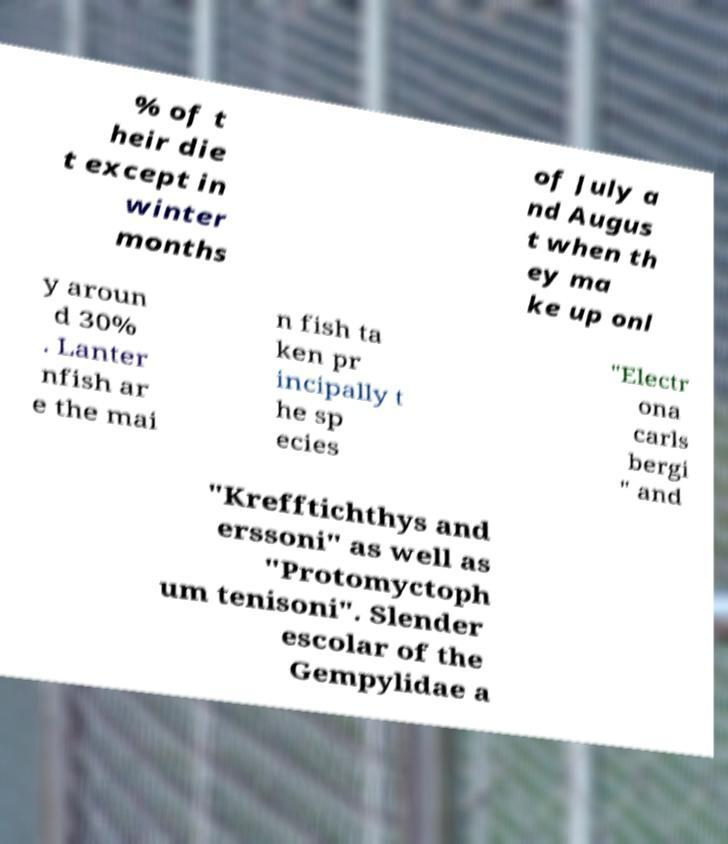For documentation purposes, I need the text within this image transcribed. Could you provide that? % of t heir die t except in winter months of July a nd Augus t when th ey ma ke up onl y aroun d 30% . Lanter nfish ar e the mai n fish ta ken pr incipally t he sp ecies "Electr ona carls bergi " and "Krefftichthys and erssoni" as well as "Protomyctoph um tenisoni". Slender escolar of the Gempylidae a 